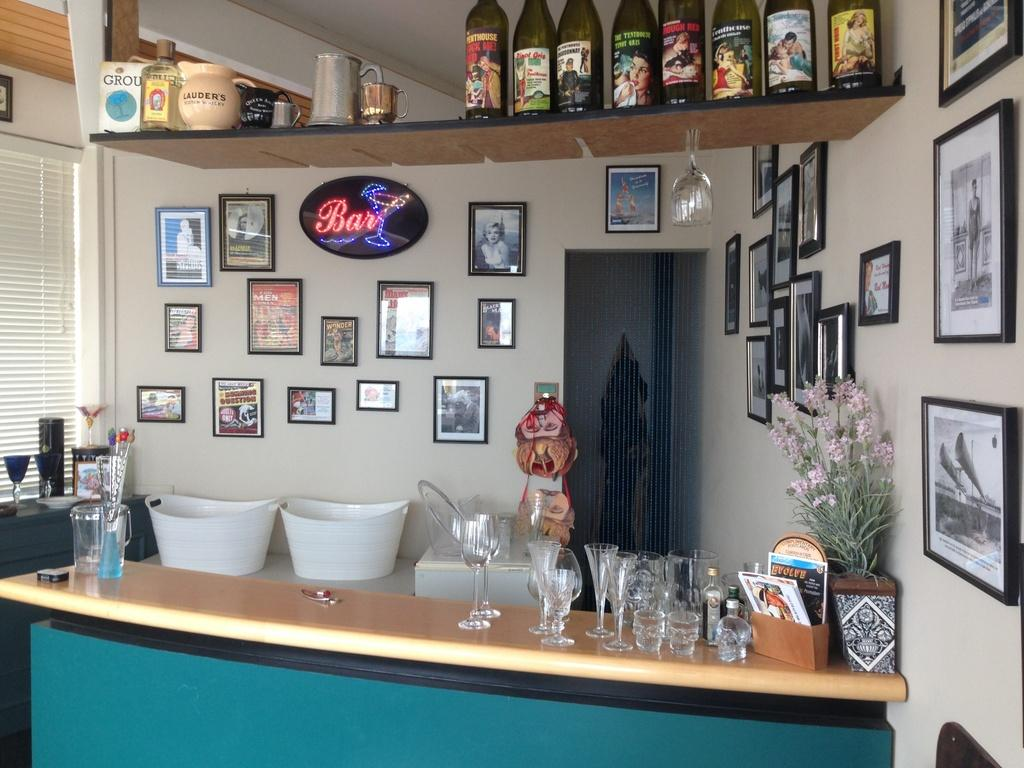<image>
Relay a brief, clear account of the picture shown. Evolve magazine is in a cardboard box with other magazine and sitting on the end of a stocked bar. 